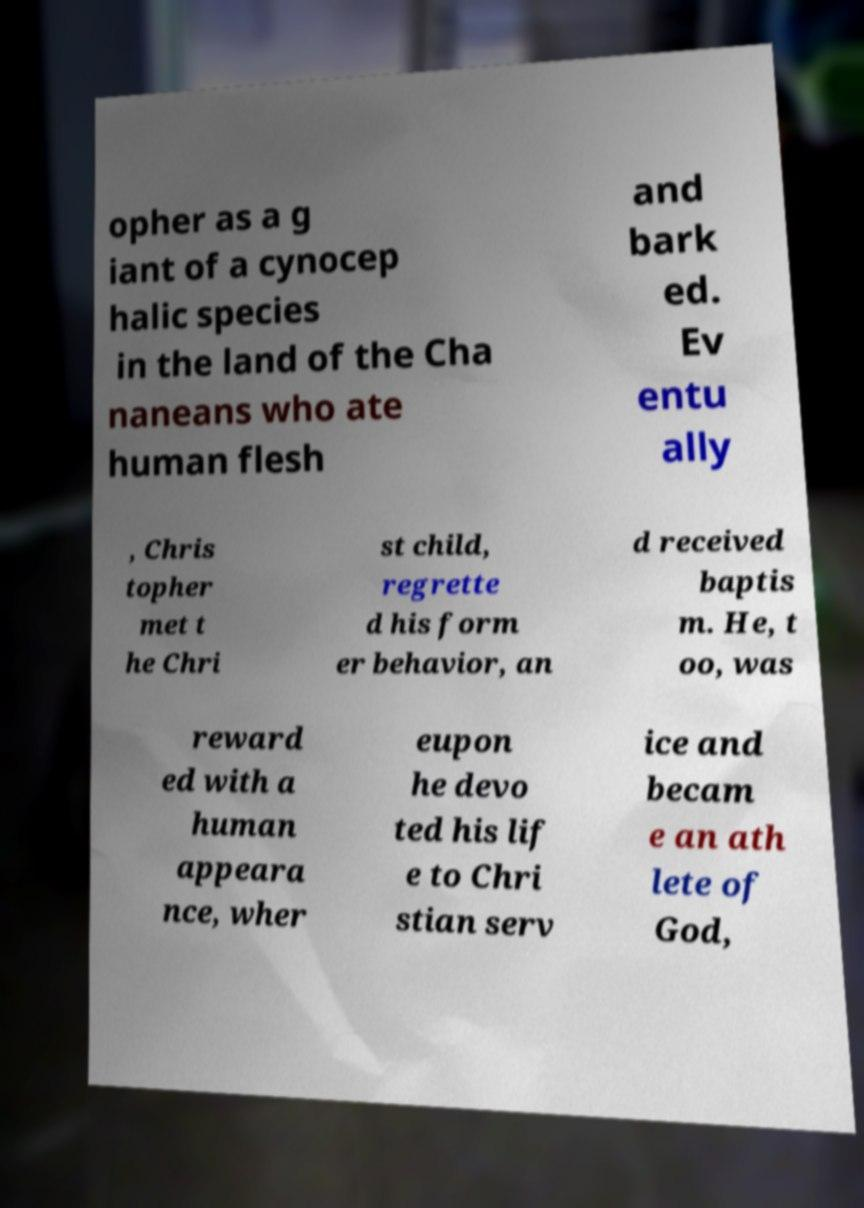Can you read and provide the text displayed in the image?This photo seems to have some interesting text. Can you extract and type it out for me? opher as a g iant of a cynocep halic species in the land of the Cha naneans who ate human flesh and bark ed. Ev entu ally , Chris topher met t he Chri st child, regrette d his form er behavior, an d received baptis m. He, t oo, was reward ed with a human appeara nce, wher eupon he devo ted his lif e to Chri stian serv ice and becam e an ath lete of God, 